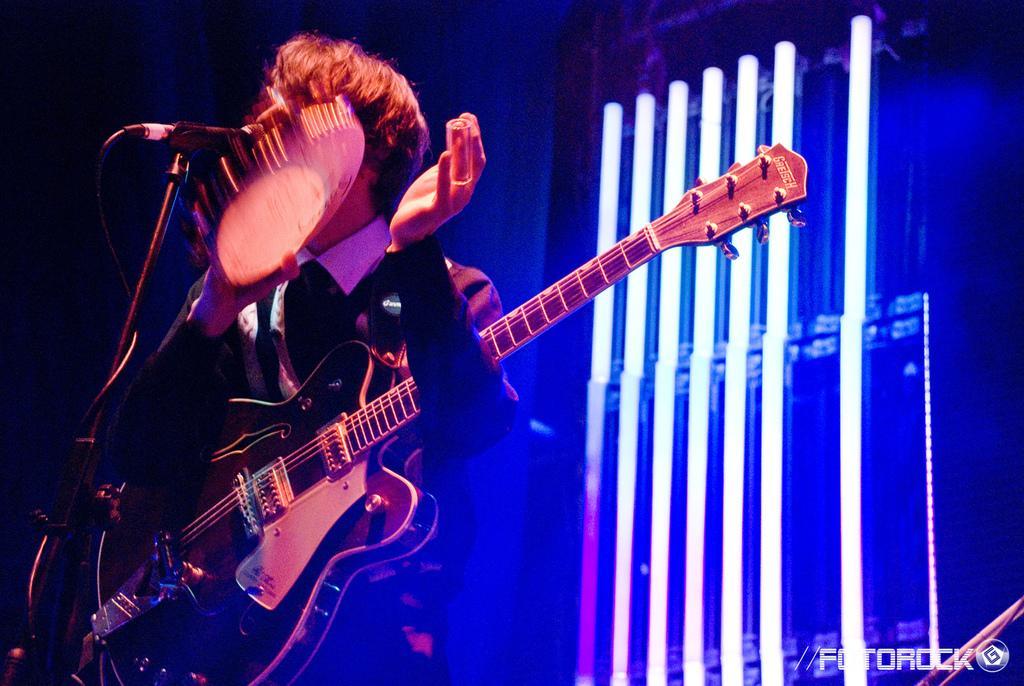Can you describe this image briefly? In this image we can see a man standing and playing a musical instrument. He is wearing a guitar, before him there is a mic placed on the stand. In the background there are lights. 